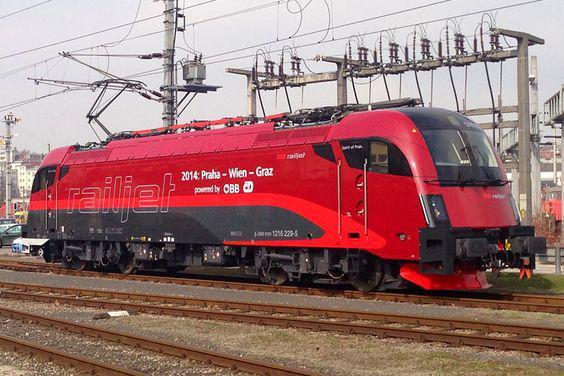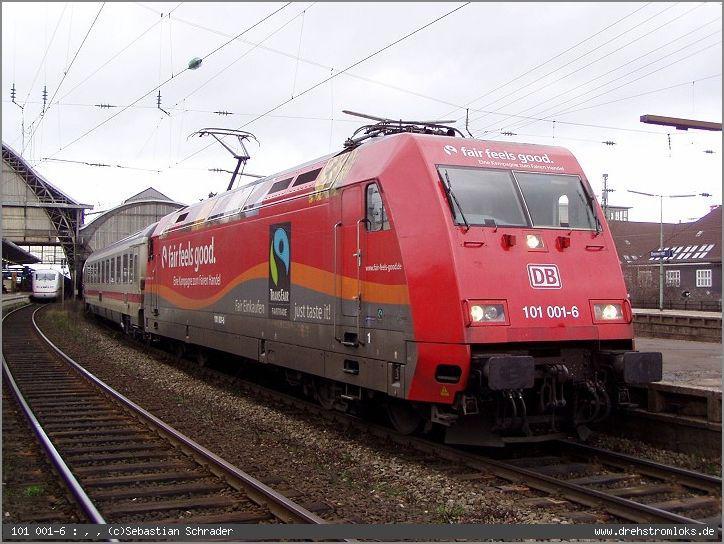The first image is the image on the left, the second image is the image on the right. Considering the images on both sides, is "There are two trains in the image on the right." valid? Answer yes or no. No. The first image is the image on the left, the second image is the image on the right. Assess this claim about the two images: "Exactly two trains in total are shown, with all trains pointing rightward.". Correct or not? Answer yes or no. Yes. 